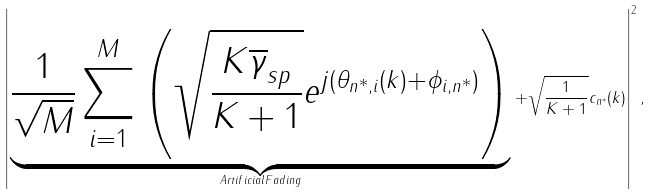<formula> <loc_0><loc_0><loc_500><loc_500>\left | \underbrace { \frac { 1 } { \sqrt { M } } \sum _ { i = 1 } ^ { M } \left ( \sqrt { \frac { K \overline { \gamma } _ { s p } } { K + 1 } } e ^ { j ( \theta _ { n ^ { * } , i } ( k ) + \phi _ { i , n ^ { * } } ) } \right ) } _ { A r t i f i c i a l F a d i n g } + \sqrt { \frac { 1 } { K + 1 } } c _ { n ^ { * } } ( k ) \right | ^ { 2 } ,</formula> 